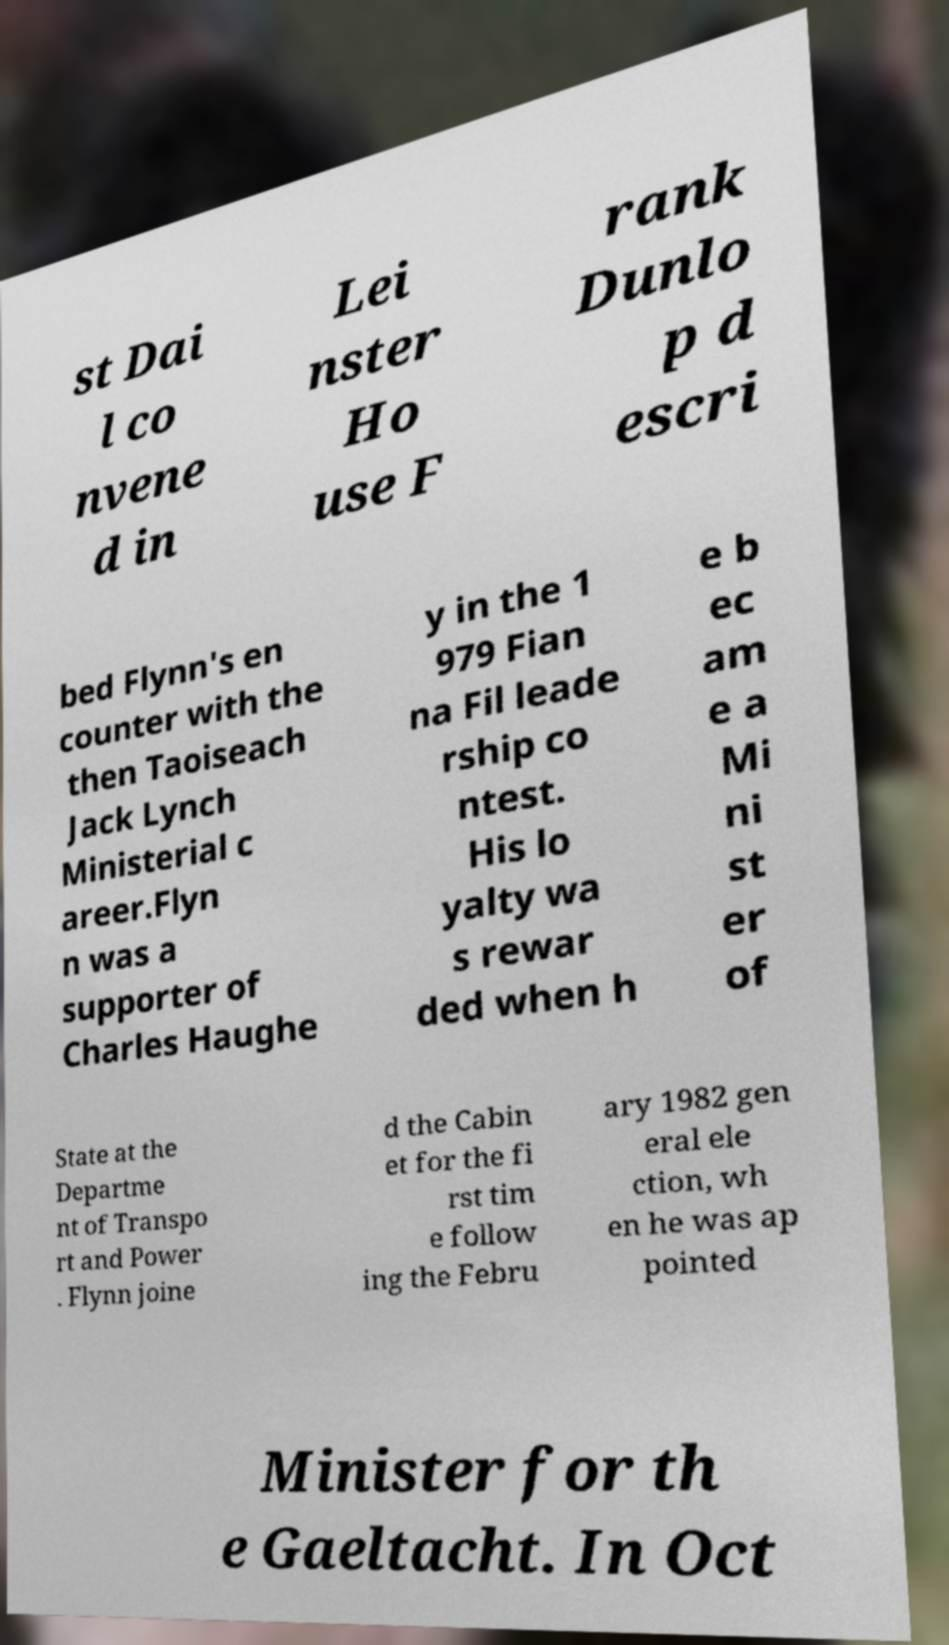Could you extract and type out the text from this image? st Dai l co nvene d in Lei nster Ho use F rank Dunlo p d escri bed Flynn's en counter with the then Taoiseach Jack Lynch Ministerial c areer.Flyn n was a supporter of Charles Haughe y in the 1 979 Fian na Fil leade rship co ntest. His lo yalty wa s rewar ded when h e b ec am e a Mi ni st er of State at the Departme nt of Transpo rt and Power . Flynn joine d the Cabin et for the fi rst tim e follow ing the Febru ary 1982 gen eral ele ction, wh en he was ap pointed Minister for th e Gaeltacht. In Oct 